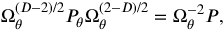<formula> <loc_0><loc_0><loc_500><loc_500>\Omega _ { \theta } ^ { ( D - 2 ) / 2 } { P _ { \theta } } \Omega _ { \theta } ^ { ( 2 - D ) / 2 } = \Omega _ { \theta } ^ { - 2 } P ,</formula> 